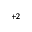Convert formula to latex. <formula><loc_0><loc_0><loc_500><loc_500>^ { + 2 }</formula> 